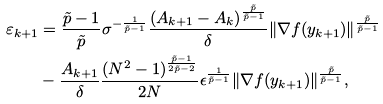<formula> <loc_0><loc_0><loc_500><loc_500>\varepsilon _ { k + 1 } & = \frac { \tilde { p } - 1 } { \tilde { p } } \sigma ^ { - \frac { 1 } { \tilde { p } - 1 } } \frac { ( A _ { k + 1 } - A _ { k } ) ^ { \frac { \tilde { p } } { \tilde { p } - 1 } } } { \delta } \| \nabla f ( y _ { k + 1 } ) \| ^ { \frac { \tilde { p } } { \tilde { p } - 1 } } \\ & - \frac { A _ { k + 1 } } { \delta } \frac { ( N ^ { 2 } - 1 ) ^ { \frac { \tilde { p } - 1 } { 2 \tilde { p } - 2 } } } { 2 N } \epsilon ^ { \frac { 1 } { \tilde { p } - 1 } } \| \nabla f ( y _ { k + 1 } ) \| ^ { \frac { \tilde { p } } { \tilde { p } - 1 } } ,</formula> 